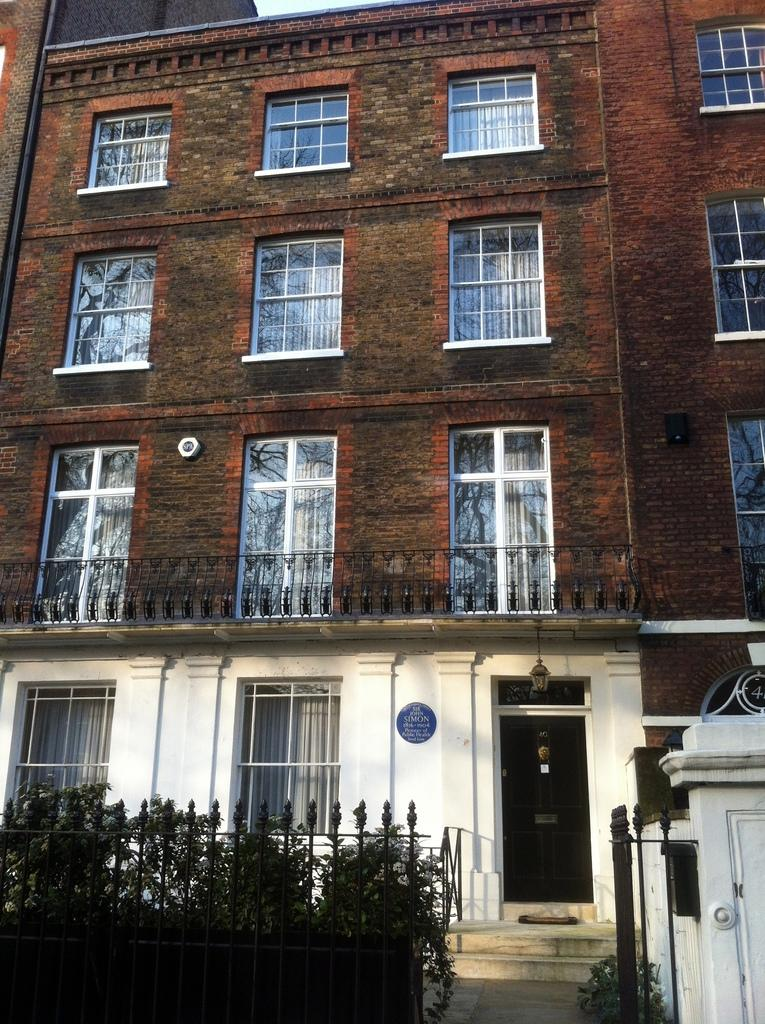What type of structure is visible in the image? There is a building in the image. What features can be seen on the building? The building has windows and a door at the bottom. What is in front of the building? There is a fencing in front of the building. Is there any access point associated with the fencing? Yes, there is a gate associated with the fencing. What can be seen on the left side of the image? There are small plants on the left side of the image. What type of throat-soothing remedy can be seen in the image? There is no throat-soothing remedy present in the image. Can you tell me how many twigs are visible in the image? There is no mention of twigs in the provided facts, so it cannot be determined how many are visible in the image. 